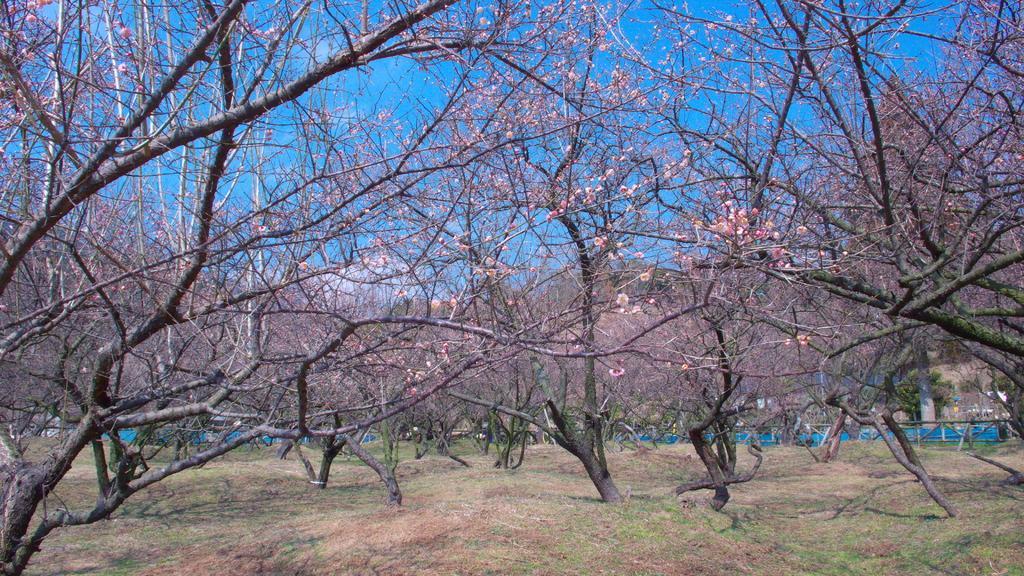Please provide a concise description of this image. In this image there are trees and there's grass on the ground. In the background there is an object which is blue in colour and there is a pillar and there is a fence. 